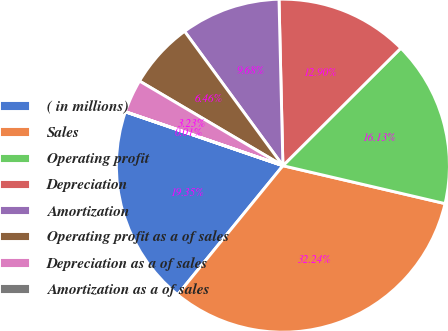Convert chart. <chart><loc_0><loc_0><loc_500><loc_500><pie_chart><fcel>( in millions)<fcel>Sales<fcel>Operating profit<fcel>Depreciation<fcel>Amortization<fcel>Operating profit as a of sales<fcel>Depreciation as a of sales<fcel>Amortization as a of sales<nl><fcel>19.35%<fcel>32.24%<fcel>16.13%<fcel>12.9%<fcel>9.68%<fcel>6.46%<fcel>3.23%<fcel>0.01%<nl></chart> 